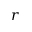<formula> <loc_0><loc_0><loc_500><loc_500>r</formula> 